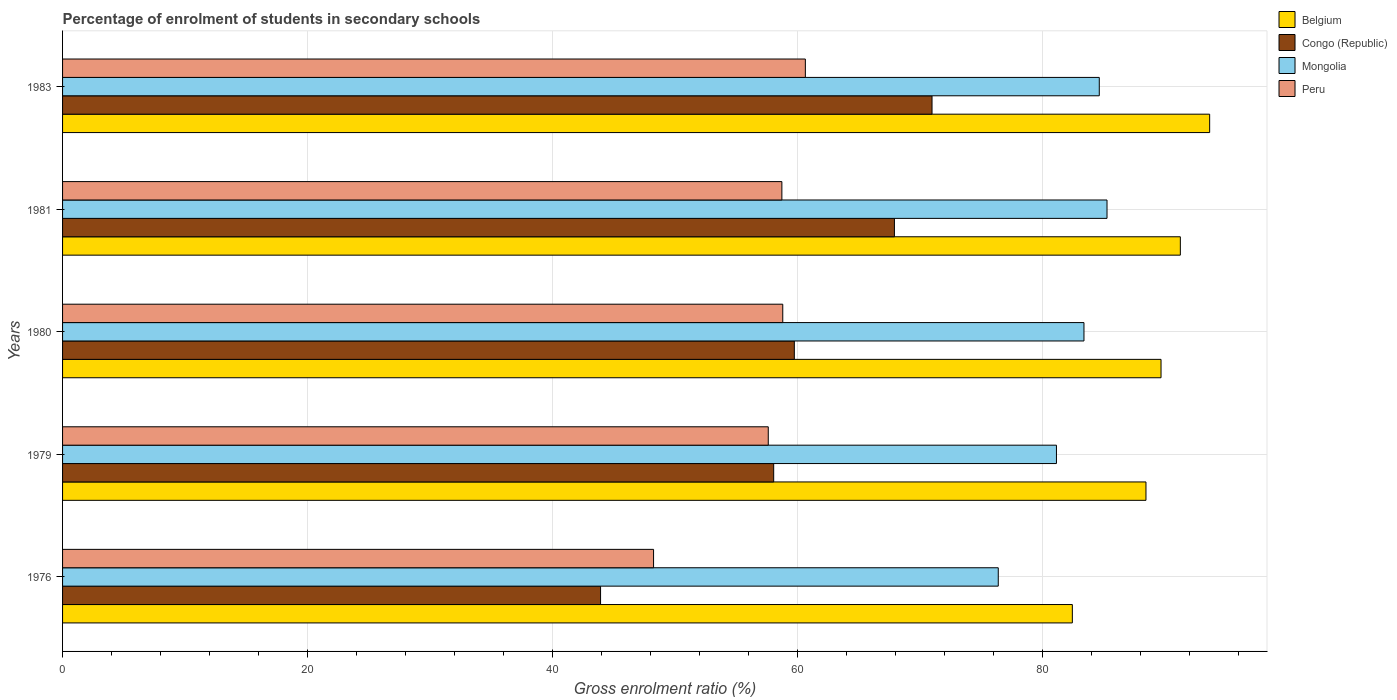How many different coloured bars are there?
Offer a very short reply. 4. How many groups of bars are there?
Provide a short and direct response. 5. Are the number of bars per tick equal to the number of legend labels?
Make the answer very short. Yes. What is the label of the 5th group of bars from the top?
Your answer should be compact. 1976. In how many cases, is the number of bars for a given year not equal to the number of legend labels?
Provide a short and direct response. 0. What is the percentage of students enrolled in secondary schools in Mongolia in 1980?
Your answer should be compact. 83.42. Across all years, what is the maximum percentage of students enrolled in secondary schools in Mongolia?
Offer a very short reply. 85.3. Across all years, what is the minimum percentage of students enrolled in secondary schools in Congo (Republic)?
Provide a succinct answer. 43.94. In which year was the percentage of students enrolled in secondary schools in Peru maximum?
Your answer should be compact. 1983. In which year was the percentage of students enrolled in secondary schools in Mongolia minimum?
Your answer should be very brief. 1976. What is the total percentage of students enrolled in secondary schools in Belgium in the graph?
Offer a very short reply. 445.63. What is the difference between the percentage of students enrolled in secondary schools in Congo (Republic) in 1980 and that in 1983?
Ensure brevity in your answer.  -11.25. What is the difference between the percentage of students enrolled in secondary schools in Belgium in 1979 and the percentage of students enrolled in secondary schools in Congo (Republic) in 1976?
Your answer should be very brief. 44.54. What is the average percentage of students enrolled in secondary schools in Congo (Republic) per year?
Your response must be concise. 60.14. In the year 1976, what is the difference between the percentage of students enrolled in secondary schools in Belgium and percentage of students enrolled in secondary schools in Congo (Republic)?
Make the answer very short. 38.53. In how many years, is the percentage of students enrolled in secondary schools in Peru greater than 92 %?
Your answer should be compact. 0. What is the ratio of the percentage of students enrolled in secondary schools in Peru in 1976 to that in 1979?
Provide a short and direct response. 0.84. Is the percentage of students enrolled in secondary schools in Belgium in 1980 less than that in 1983?
Offer a terse response. Yes. Is the difference between the percentage of students enrolled in secondary schools in Belgium in 1976 and 1983 greater than the difference between the percentage of students enrolled in secondary schools in Congo (Republic) in 1976 and 1983?
Make the answer very short. Yes. What is the difference between the highest and the second highest percentage of students enrolled in secondary schools in Peru?
Ensure brevity in your answer.  1.84. What is the difference between the highest and the lowest percentage of students enrolled in secondary schools in Peru?
Keep it short and to the point. 12.4. What does the 2nd bar from the top in 1983 represents?
Offer a very short reply. Mongolia. What does the 2nd bar from the bottom in 1983 represents?
Your answer should be very brief. Congo (Republic). Is it the case that in every year, the sum of the percentage of students enrolled in secondary schools in Congo (Republic) and percentage of students enrolled in secondary schools in Peru is greater than the percentage of students enrolled in secondary schools in Belgium?
Provide a short and direct response. Yes. How many bars are there?
Offer a terse response. 20. What is the difference between two consecutive major ticks on the X-axis?
Your answer should be compact. 20. Are the values on the major ticks of X-axis written in scientific E-notation?
Offer a very short reply. No. Does the graph contain any zero values?
Provide a succinct answer. No. How many legend labels are there?
Provide a succinct answer. 4. How are the legend labels stacked?
Your answer should be compact. Vertical. What is the title of the graph?
Offer a very short reply. Percentage of enrolment of students in secondary schools. Does "Cuba" appear as one of the legend labels in the graph?
Ensure brevity in your answer.  No. What is the label or title of the Y-axis?
Ensure brevity in your answer.  Years. What is the Gross enrolment ratio (%) in Belgium in 1976?
Offer a very short reply. 82.47. What is the Gross enrolment ratio (%) in Congo (Republic) in 1976?
Provide a short and direct response. 43.94. What is the Gross enrolment ratio (%) in Mongolia in 1976?
Provide a succinct answer. 76.42. What is the Gross enrolment ratio (%) in Peru in 1976?
Your answer should be compact. 48.27. What is the Gross enrolment ratio (%) of Belgium in 1979?
Make the answer very short. 88.48. What is the Gross enrolment ratio (%) of Congo (Republic) in 1979?
Provide a succinct answer. 58.08. What is the Gross enrolment ratio (%) in Mongolia in 1979?
Keep it short and to the point. 81.17. What is the Gross enrolment ratio (%) of Peru in 1979?
Your response must be concise. 57.63. What is the Gross enrolment ratio (%) in Belgium in 1980?
Make the answer very short. 89.71. What is the Gross enrolment ratio (%) in Congo (Republic) in 1980?
Make the answer very short. 59.76. What is the Gross enrolment ratio (%) in Mongolia in 1980?
Offer a very short reply. 83.42. What is the Gross enrolment ratio (%) in Peru in 1980?
Offer a very short reply. 58.82. What is the Gross enrolment ratio (%) of Belgium in 1981?
Make the answer very short. 91.29. What is the Gross enrolment ratio (%) in Congo (Republic) in 1981?
Provide a succinct answer. 67.94. What is the Gross enrolment ratio (%) in Mongolia in 1981?
Offer a very short reply. 85.3. What is the Gross enrolment ratio (%) of Peru in 1981?
Provide a succinct answer. 58.74. What is the Gross enrolment ratio (%) of Belgium in 1983?
Your answer should be compact. 93.68. What is the Gross enrolment ratio (%) of Congo (Republic) in 1983?
Provide a short and direct response. 71.01. What is the Gross enrolment ratio (%) in Mongolia in 1983?
Ensure brevity in your answer.  84.67. What is the Gross enrolment ratio (%) in Peru in 1983?
Your answer should be compact. 60.66. Across all years, what is the maximum Gross enrolment ratio (%) in Belgium?
Offer a very short reply. 93.68. Across all years, what is the maximum Gross enrolment ratio (%) in Congo (Republic)?
Give a very brief answer. 71.01. Across all years, what is the maximum Gross enrolment ratio (%) of Mongolia?
Your response must be concise. 85.3. Across all years, what is the maximum Gross enrolment ratio (%) of Peru?
Offer a terse response. 60.66. Across all years, what is the minimum Gross enrolment ratio (%) in Belgium?
Offer a terse response. 82.47. Across all years, what is the minimum Gross enrolment ratio (%) in Congo (Republic)?
Your answer should be very brief. 43.94. Across all years, what is the minimum Gross enrolment ratio (%) in Mongolia?
Provide a succinct answer. 76.42. Across all years, what is the minimum Gross enrolment ratio (%) of Peru?
Offer a terse response. 48.27. What is the total Gross enrolment ratio (%) in Belgium in the graph?
Your answer should be very brief. 445.63. What is the total Gross enrolment ratio (%) of Congo (Republic) in the graph?
Provide a short and direct response. 300.72. What is the total Gross enrolment ratio (%) of Mongolia in the graph?
Offer a very short reply. 410.97. What is the total Gross enrolment ratio (%) in Peru in the graph?
Ensure brevity in your answer.  284.12. What is the difference between the Gross enrolment ratio (%) in Belgium in 1976 and that in 1979?
Provide a short and direct response. -6.01. What is the difference between the Gross enrolment ratio (%) of Congo (Republic) in 1976 and that in 1979?
Ensure brevity in your answer.  -14.14. What is the difference between the Gross enrolment ratio (%) of Mongolia in 1976 and that in 1979?
Give a very brief answer. -4.75. What is the difference between the Gross enrolment ratio (%) in Peru in 1976 and that in 1979?
Your response must be concise. -9.37. What is the difference between the Gross enrolment ratio (%) of Belgium in 1976 and that in 1980?
Make the answer very short. -7.24. What is the difference between the Gross enrolment ratio (%) of Congo (Republic) in 1976 and that in 1980?
Your response must be concise. -15.82. What is the difference between the Gross enrolment ratio (%) of Mongolia in 1976 and that in 1980?
Give a very brief answer. -7. What is the difference between the Gross enrolment ratio (%) of Peru in 1976 and that in 1980?
Your response must be concise. -10.55. What is the difference between the Gross enrolment ratio (%) of Belgium in 1976 and that in 1981?
Ensure brevity in your answer.  -8.82. What is the difference between the Gross enrolment ratio (%) of Congo (Republic) in 1976 and that in 1981?
Keep it short and to the point. -24. What is the difference between the Gross enrolment ratio (%) of Mongolia in 1976 and that in 1981?
Keep it short and to the point. -8.88. What is the difference between the Gross enrolment ratio (%) in Peru in 1976 and that in 1981?
Your answer should be compact. -10.48. What is the difference between the Gross enrolment ratio (%) of Belgium in 1976 and that in 1983?
Keep it short and to the point. -11.21. What is the difference between the Gross enrolment ratio (%) in Congo (Republic) in 1976 and that in 1983?
Provide a succinct answer. -27.07. What is the difference between the Gross enrolment ratio (%) of Mongolia in 1976 and that in 1983?
Offer a very short reply. -8.25. What is the difference between the Gross enrolment ratio (%) in Peru in 1976 and that in 1983?
Offer a very short reply. -12.4. What is the difference between the Gross enrolment ratio (%) in Belgium in 1979 and that in 1980?
Keep it short and to the point. -1.23. What is the difference between the Gross enrolment ratio (%) of Congo (Republic) in 1979 and that in 1980?
Your answer should be compact. -1.69. What is the difference between the Gross enrolment ratio (%) of Mongolia in 1979 and that in 1980?
Make the answer very short. -2.25. What is the difference between the Gross enrolment ratio (%) of Peru in 1979 and that in 1980?
Make the answer very short. -1.18. What is the difference between the Gross enrolment ratio (%) in Belgium in 1979 and that in 1981?
Keep it short and to the point. -2.81. What is the difference between the Gross enrolment ratio (%) in Congo (Republic) in 1979 and that in 1981?
Ensure brevity in your answer.  -9.86. What is the difference between the Gross enrolment ratio (%) of Mongolia in 1979 and that in 1981?
Give a very brief answer. -4.13. What is the difference between the Gross enrolment ratio (%) in Peru in 1979 and that in 1981?
Ensure brevity in your answer.  -1.11. What is the difference between the Gross enrolment ratio (%) in Belgium in 1979 and that in 1983?
Keep it short and to the point. -5.2. What is the difference between the Gross enrolment ratio (%) of Congo (Republic) in 1979 and that in 1983?
Keep it short and to the point. -12.93. What is the difference between the Gross enrolment ratio (%) in Mongolia in 1979 and that in 1983?
Your answer should be compact. -3.5. What is the difference between the Gross enrolment ratio (%) in Peru in 1979 and that in 1983?
Your response must be concise. -3.03. What is the difference between the Gross enrolment ratio (%) in Belgium in 1980 and that in 1981?
Offer a very short reply. -1.58. What is the difference between the Gross enrolment ratio (%) in Congo (Republic) in 1980 and that in 1981?
Your response must be concise. -8.18. What is the difference between the Gross enrolment ratio (%) of Mongolia in 1980 and that in 1981?
Ensure brevity in your answer.  -1.88. What is the difference between the Gross enrolment ratio (%) in Peru in 1980 and that in 1981?
Offer a very short reply. 0.07. What is the difference between the Gross enrolment ratio (%) of Belgium in 1980 and that in 1983?
Your response must be concise. -3.97. What is the difference between the Gross enrolment ratio (%) of Congo (Republic) in 1980 and that in 1983?
Your answer should be very brief. -11.25. What is the difference between the Gross enrolment ratio (%) of Mongolia in 1980 and that in 1983?
Give a very brief answer. -1.25. What is the difference between the Gross enrolment ratio (%) of Peru in 1980 and that in 1983?
Offer a very short reply. -1.84. What is the difference between the Gross enrolment ratio (%) in Belgium in 1981 and that in 1983?
Keep it short and to the point. -2.39. What is the difference between the Gross enrolment ratio (%) in Congo (Republic) in 1981 and that in 1983?
Your answer should be compact. -3.07. What is the difference between the Gross enrolment ratio (%) of Mongolia in 1981 and that in 1983?
Offer a very short reply. 0.63. What is the difference between the Gross enrolment ratio (%) of Peru in 1981 and that in 1983?
Make the answer very short. -1.92. What is the difference between the Gross enrolment ratio (%) of Belgium in 1976 and the Gross enrolment ratio (%) of Congo (Republic) in 1979?
Make the answer very short. 24.39. What is the difference between the Gross enrolment ratio (%) in Belgium in 1976 and the Gross enrolment ratio (%) in Mongolia in 1979?
Your response must be concise. 1.3. What is the difference between the Gross enrolment ratio (%) in Belgium in 1976 and the Gross enrolment ratio (%) in Peru in 1979?
Your response must be concise. 24.83. What is the difference between the Gross enrolment ratio (%) of Congo (Republic) in 1976 and the Gross enrolment ratio (%) of Mongolia in 1979?
Your answer should be very brief. -37.23. What is the difference between the Gross enrolment ratio (%) in Congo (Republic) in 1976 and the Gross enrolment ratio (%) in Peru in 1979?
Offer a terse response. -13.7. What is the difference between the Gross enrolment ratio (%) in Mongolia in 1976 and the Gross enrolment ratio (%) in Peru in 1979?
Offer a terse response. 18.78. What is the difference between the Gross enrolment ratio (%) in Belgium in 1976 and the Gross enrolment ratio (%) in Congo (Republic) in 1980?
Give a very brief answer. 22.71. What is the difference between the Gross enrolment ratio (%) of Belgium in 1976 and the Gross enrolment ratio (%) of Mongolia in 1980?
Your response must be concise. -0.95. What is the difference between the Gross enrolment ratio (%) of Belgium in 1976 and the Gross enrolment ratio (%) of Peru in 1980?
Give a very brief answer. 23.65. What is the difference between the Gross enrolment ratio (%) in Congo (Republic) in 1976 and the Gross enrolment ratio (%) in Mongolia in 1980?
Your answer should be very brief. -39.48. What is the difference between the Gross enrolment ratio (%) in Congo (Republic) in 1976 and the Gross enrolment ratio (%) in Peru in 1980?
Provide a short and direct response. -14.88. What is the difference between the Gross enrolment ratio (%) in Mongolia in 1976 and the Gross enrolment ratio (%) in Peru in 1980?
Give a very brief answer. 17.6. What is the difference between the Gross enrolment ratio (%) in Belgium in 1976 and the Gross enrolment ratio (%) in Congo (Republic) in 1981?
Offer a very short reply. 14.53. What is the difference between the Gross enrolment ratio (%) of Belgium in 1976 and the Gross enrolment ratio (%) of Mongolia in 1981?
Your answer should be compact. -2.83. What is the difference between the Gross enrolment ratio (%) in Belgium in 1976 and the Gross enrolment ratio (%) in Peru in 1981?
Make the answer very short. 23.72. What is the difference between the Gross enrolment ratio (%) in Congo (Republic) in 1976 and the Gross enrolment ratio (%) in Mongolia in 1981?
Keep it short and to the point. -41.36. What is the difference between the Gross enrolment ratio (%) of Congo (Republic) in 1976 and the Gross enrolment ratio (%) of Peru in 1981?
Provide a succinct answer. -14.81. What is the difference between the Gross enrolment ratio (%) in Mongolia in 1976 and the Gross enrolment ratio (%) in Peru in 1981?
Give a very brief answer. 17.67. What is the difference between the Gross enrolment ratio (%) of Belgium in 1976 and the Gross enrolment ratio (%) of Congo (Republic) in 1983?
Your answer should be very brief. 11.46. What is the difference between the Gross enrolment ratio (%) in Belgium in 1976 and the Gross enrolment ratio (%) in Mongolia in 1983?
Keep it short and to the point. -2.2. What is the difference between the Gross enrolment ratio (%) in Belgium in 1976 and the Gross enrolment ratio (%) in Peru in 1983?
Offer a terse response. 21.81. What is the difference between the Gross enrolment ratio (%) in Congo (Republic) in 1976 and the Gross enrolment ratio (%) in Mongolia in 1983?
Your answer should be very brief. -40.73. What is the difference between the Gross enrolment ratio (%) in Congo (Republic) in 1976 and the Gross enrolment ratio (%) in Peru in 1983?
Keep it short and to the point. -16.73. What is the difference between the Gross enrolment ratio (%) in Mongolia in 1976 and the Gross enrolment ratio (%) in Peru in 1983?
Ensure brevity in your answer.  15.75. What is the difference between the Gross enrolment ratio (%) in Belgium in 1979 and the Gross enrolment ratio (%) in Congo (Republic) in 1980?
Make the answer very short. 28.72. What is the difference between the Gross enrolment ratio (%) in Belgium in 1979 and the Gross enrolment ratio (%) in Mongolia in 1980?
Keep it short and to the point. 5.06. What is the difference between the Gross enrolment ratio (%) in Belgium in 1979 and the Gross enrolment ratio (%) in Peru in 1980?
Ensure brevity in your answer.  29.66. What is the difference between the Gross enrolment ratio (%) in Congo (Republic) in 1979 and the Gross enrolment ratio (%) in Mongolia in 1980?
Keep it short and to the point. -25.34. What is the difference between the Gross enrolment ratio (%) of Congo (Republic) in 1979 and the Gross enrolment ratio (%) of Peru in 1980?
Make the answer very short. -0.74. What is the difference between the Gross enrolment ratio (%) in Mongolia in 1979 and the Gross enrolment ratio (%) in Peru in 1980?
Keep it short and to the point. 22.35. What is the difference between the Gross enrolment ratio (%) in Belgium in 1979 and the Gross enrolment ratio (%) in Congo (Republic) in 1981?
Offer a very short reply. 20.54. What is the difference between the Gross enrolment ratio (%) in Belgium in 1979 and the Gross enrolment ratio (%) in Mongolia in 1981?
Make the answer very short. 3.18. What is the difference between the Gross enrolment ratio (%) in Belgium in 1979 and the Gross enrolment ratio (%) in Peru in 1981?
Give a very brief answer. 29.73. What is the difference between the Gross enrolment ratio (%) of Congo (Republic) in 1979 and the Gross enrolment ratio (%) of Mongolia in 1981?
Provide a succinct answer. -27.22. What is the difference between the Gross enrolment ratio (%) in Congo (Republic) in 1979 and the Gross enrolment ratio (%) in Peru in 1981?
Your response must be concise. -0.67. What is the difference between the Gross enrolment ratio (%) in Mongolia in 1979 and the Gross enrolment ratio (%) in Peru in 1981?
Offer a very short reply. 22.42. What is the difference between the Gross enrolment ratio (%) of Belgium in 1979 and the Gross enrolment ratio (%) of Congo (Republic) in 1983?
Make the answer very short. 17.47. What is the difference between the Gross enrolment ratio (%) of Belgium in 1979 and the Gross enrolment ratio (%) of Mongolia in 1983?
Your response must be concise. 3.81. What is the difference between the Gross enrolment ratio (%) in Belgium in 1979 and the Gross enrolment ratio (%) in Peru in 1983?
Your answer should be very brief. 27.82. What is the difference between the Gross enrolment ratio (%) in Congo (Republic) in 1979 and the Gross enrolment ratio (%) in Mongolia in 1983?
Your answer should be compact. -26.59. What is the difference between the Gross enrolment ratio (%) of Congo (Republic) in 1979 and the Gross enrolment ratio (%) of Peru in 1983?
Offer a very short reply. -2.59. What is the difference between the Gross enrolment ratio (%) of Mongolia in 1979 and the Gross enrolment ratio (%) of Peru in 1983?
Give a very brief answer. 20.51. What is the difference between the Gross enrolment ratio (%) of Belgium in 1980 and the Gross enrolment ratio (%) of Congo (Republic) in 1981?
Keep it short and to the point. 21.77. What is the difference between the Gross enrolment ratio (%) in Belgium in 1980 and the Gross enrolment ratio (%) in Mongolia in 1981?
Offer a very short reply. 4.41. What is the difference between the Gross enrolment ratio (%) of Belgium in 1980 and the Gross enrolment ratio (%) of Peru in 1981?
Give a very brief answer. 30.97. What is the difference between the Gross enrolment ratio (%) in Congo (Republic) in 1980 and the Gross enrolment ratio (%) in Mongolia in 1981?
Ensure brevity in your answer.  -25.54. What is the difference between the Gross enrolment ratio (%) of Mongolia in 1980 and the Gross enrolment ratio (%) of Peru in 1981?
Give a very brief answer. 24.67. What is the difference between the Gross enrolment ratio (%) of Belgium in 1980 and the Gross enrolment ratio (%) of Congo (Republic) in 1983?
Offer a terse response. 18.7. What is the difference between the Gross enrolment ratio (%) in Belgium in 1980 and the Gross enrolment ratio (%) in Mongolia in 1983?
Make the answer very short. 5.04. What is the difference between the Gross enrolment ratio (%) in Belgium in 1980 and the Gross enrolment ratio (%) in Peru in 1983?
Give a very brief answer. 29.05. What is the difference between the Gross enrolment ratio (%) of Congo (Republic) in 1980 and the Gross enrolment ratio (%) of Mongolia in 1983?
Offer a terse response. -24.91. What is the difference between the Gross enrolment ratio (%) in Congo (Republic) in 1980 and the Gross enrolment ratio (%) in Peru in 1983?
Your response must be concise. -0.9. What is the difference between the Gross enrolment ratio (%) in Mongolia in 1980 and the Gross enrolment ratio (%) in Peru in 1983?
Your response must be concise. 22.75. What is the difference between the Gross enrolment ratio (%) in Belgium in 1981 and the Gross enrolment ratio (%) in Congo (Republic) in 1983?
Provide a short and direct response. 20.28. What is the difference between the Gross enrolment ratio (%) in Belgium in 1981 and the Gross enrolment ratio (%) in Mongolia in 1983?
Your response must be concise. 6.62. What is the difference between the Gross enrolment ratio (%) of Belgium in 1981 and the Gross enrolment ratio (%) of Peru in 1983?
Make the answer very short. 30.63. What is the difference between the Gross enrolment ratio (%) in Congo (Republic) in 1981 and the Gross enrolment ratio (%) in Mongolia in 1983?
Make the answer very short. -16.73. What is the difference between the Gross enrolment ratio (%) of Congo (Republic) in 1981 and the Gross enrolment ratio (%) of Peru in 1983?
Your response must be concise. 7.27. What is the difference between the Gross enrolment ratio (%) in Mongolia in 1981 and the Gross enrolment ratio (%) in Peru in 1983?
Give a very brief answer. 24.64. What is the average Gross enrolment ratio (%) of Belgium per year?
Your answer should be compact. 89.13. What is the average Gross enrolment ratio (%) of Congo (Republic) per year?
Offer a very short reply. 60.14. What is the average Gross enrolment ratio (%) of Mongolia per year?
Ensure brevity in your answer.  82.19. What is the average Gross enrolment ratio (%) in Peru per year?
Keep it short and to the point. 56.83. In the year 1976, what is the difference between the Gross enrolment ratio (%) in Belgium and Gross enrolment ratio (%) in Congo (Republic)?
Your answer should be compact. 38.53. In the year 1976, what is the difference between the Gross enrolment ratio (%) in Belgium and Gross enrolment ratio (%) in Mongolia?
Provide a succinct answer. 6.05. In the year 1976, what is the difference between the Gross enrolment ratio (%) of Belgium and Gross enrolment ratio (%) of Peru?
Give a very brief answer. 34.2. In the year 1976, what is the difference between the Gross enrolment ratio (%) in Congo (Republic) and Gross enrolment ratio (%) in Mongolia?
Give a very brief answer. -32.48. In the year 1976, what is the difference between the Gross enrolment ratio (%) in Congo (Republic) and Gross enrolment ratio (%) in Peru?
Make the answer very short. -4.33. In the year 1976, what is the difference between the Gross enrolment ratio (%) in Mongolia and Gross enrolment ratio (%) in Peru?
Provide a short and direct response. 28.15. In the year 1979, what is the difference between the Gross enrolment ratio (%) of Belgium and Gross enrolment ratio (%) of Congo (Republic)?
Provide a short and direct response. 30.4. In the year 1979, what is the difference between the Gross enrolment ratio (%) in Belgium and Gross enrolment ratio (%) in Mongolia?
Your answer should be very brief. 7.31. In the year 1979, what is the difference between the Gross enrolment ratio (%) in Belgium and Gross enrolment ratio (%) in Peru?
Your answer should be very brief. 30.85. In the year 1979, what is the difference between the Gross enrolment ratio (%) of Congo (Republic) and Gross enrolment ratio (%) of Mongolia?
Your response must be concise. -23.09. In the year 1979, what is the difference between the Gross enrolment ratio (%) of Congo (Republic) and Gross enrolment ratio (%) of Peru?
Your answer should be very brief. 0.44. In the year 1979, what is the difference between the Gross enrolment ratio (%) in Mongolia and Gross enrolment ratio (%) in Peru?
Offer a very short reply. 23.54. In the year 1980, what is the difference between the Gross enrolment ratio (%) in Belgium and Gross enrolment ratio (%) in Congo (Republic)?
Your answer should be very brief. 29.95. In the year 1980, what is the difference between the Gross enrolment ratio (%) of Belgium and Gross enrolment ratio (%) of Mongolia?
Keep it short and to the point. 6.29. In the year 1980, what is the difference between the Gross enrolment ratio (%) of Belgium and Gross enrolment ratio (%) of Peru?
Make the answer very short. 30.89. In the year 1980, what is the difference between the Gross enrolment ratio (%) of Congo (Republic) and Gross enrolment ratio (%) of Mongolia?
Your answer should be very brief. -23.66. In the year 1980, what is the difference between the Gross enrolment ratio (%) in Congo (Republic) and Gross enrolment ratio (%) in Peru?
Make the answer very short. 0.94. In the year 1980, what is the difference between the Gross enrolment ratio (%) of Mongolia and Gross enrolment ratio (%) of Peru?
Provide a short and direct response. 24.6. In the year 1981, what is the difference between the Gross enrolment ratio (%) in Belgium and Gross enrolment ratio (%) in Congo (Republic)?
Ensure brevity in your answer.  23.35. In the year 1981, what is the difference between the Gross enrolment ratio (%) of Belgium and Gross enrolment ratio (%) of Mongolia?
Make the answer very short. 5.99. In the year 1981, what is the difference between the Gross enrolment ratio (%) of Belgium and Gross enrolment ratio (%) of Peru?
Ensure brevity in your answer.  32.54. In the year 1981, what is the difference between the Gross enrolment ratio (%) of Congo (Republic) and Gross enrolment ratio (%) of Mongolia?
Your answer should be compact. -17.36. In the year 1981, what is the difference between the Gross enrolment ratio (%) of Congo (Republic) and Gross enrolment ratio (%) of Peru?
Give a very brief answer. 9.19. In the year 1981, what is the difference between the Gross enrolment ratio (%) of Mongolia and Gross enrolment ratio (%) of Peru?
Offer a terse response. 26.55. In the year 1983, what is the difference between the Gross enrolment ratio (%) in Belgium and Gross enrolment ratio (%) in Congo (Republic)?
Offer a very short reply. 22.67. In the year 1983, what is the difference between the Gross enrolment ratio (%) of Belgium and Gross enrolment ratio (%) of Mongolia?
Provide a short and direct response. 9.01. In the year 1983, what is the difference between the Gross enrolment ratio (%) in Belgium and Gross enrolment ratio (%) in Peru?
Offer a terse response. 33.02. In the year 1983, what is the difference between the Gross enrolment ratio (%) of Congo (Republic) and Gross enrolment ratio (%) of Mongolia?
Offer a terse response. -13.66. In the year 1983, what is the difference between the Gross enrolment ratio (%) of Congo (Republic) and Gross enrolment ratio (%) of Peru?
Offer a terse response. 10.35. In the year 1983, what is the difference between the Gross enrolment ratio (%) of Mongolia and Gross enrolment ratio (%) of Peru?
Your response must be concise. 24.01. What is the ratio of the Gross enrolment ratio (%) in Belgium in 1976 to that in 1979?
Ensure brevity in your answer.  0.93. What is the ratio of the Gross enrolment ratio (%) in Congo (Republic) in 1976 to that in 1979?
Ensure brevity in your answer.  0.76. What is the ratio of the Gross enrolment ratio (%) of Mongolia in 1976 to that in 1979?
Ensure brevity in your answer.  0.94. What is the ratio of the Gross enrolment ratio (%) in Peru in 1976 to that in 1979?
Make the answer very short. 0.84. What is the ratio of the Gross enrolment ratio (%) in Belgium in 1976 to that in 1980?
Keep it short and to the point. 0.92. What is the ratio of the Gross enrolment ratio (%) in Congo (Republic) in 1976 to that in 1980?
Keep it short and to the point. 0.74. What is the ratio of the Gross enrolment ratio (%) in Mongolia in 1976 to that in 1980?
Your answer should be compact. 0.92. What is the ratio of the Gross enrolment ratio (%) of Peru in 1976 to that in 1980?
Make the answer very short. 0.82. What is the ratio of the Gross enrolment ratio (%) of Belgium in 1976 to that in 1981?
Ensure brevity in your answer.  0.9. What is the ratio of the Gross enrolment ratio (%) of Congo (Republic) in 1976 to that in 1981?
Your answer should be very brief. 0.65. What is the ratio of the Gross enrolment ratio (%) in Mongolia in 1976 to that in 1981?
Offer a very short reply. 0.9. What is the ratio of the Gross enrolment ratio (%) of Peru in 1976 to that in 1981?
Your answer should be very brief. 0.82. What is the ratio of the Gross enrolment ratio (%) of Belgium in 1976 to that in 1983?
Your response must be concise. 0.88. What is the ratio of the Gross enrolment ratio (%) of Congo (Republic) in 1976 to that in 1983?
Offer a very short reply. 0.62. What is the ratio of the Gross enrolment ratio (%) of Mongolia in 1976 to that in 1983?
Your answer should be compact. 0.9. What is the ratio of the Gross enrolment ratio (%) in Peru in 1976 to that in 1983?
Your answer should be compact. 0.8. What is the ratio of the Gross enrolment ratio (%) in Belgium in 1979 to that in 1980?
Ensure brevity in your answer.  0.99. What is the ratio of the Gross enrolment ratio (%) of Congo (Republic) in 1979 to that in 1980?
Your response must be concise. 0.97. What is the ratio of the Gross enrolment ratio (%) of Mongolia in 1979 to that in 1980?
Provide a short and direct response. 0.97. What is the ratio of the Gross enrolment ratio (%) of Peru in 1979 to that in 1980?
Provide a succinct answer. 0.98. What is the ratio of the Gross enrolment ratio (%) in Belgium in 1979 to that in 1981?
Provide a short and direct response. 0.97. What is the ratio of the Gross enrolment ratio (%) of Congo (Republic) in 1979 to that in 1981?
Keep it short and to the point. 0.85. What is the ratio of the Gross enrolment ratio (%) in Mongolia in 1979 to that in 1981?
Your answer should be compact. 0.95. What is the ratio of the Gross enrolment ratio (%) of Peru in 1979 to that in 1981?
Make the answer very short. 0.98. What is the ratio of the Gross enrolment ratio (%) of Belgium in 1979 to that in 1983?
Offer a terse response. 0.94. What is the ratio of the Gross enrolment ratio (%) in Congo (Republic) in 1979 to that in 1983?
Your response must be concise. 0.82. What is the ratio of the Gross enrolment ratio (%) in Mongolia in 1979 to that in 1983?
Your answer should be very brief. 0.96. What is the ratio of the Gross enrolment ratio (%) in Peru in 1979 to that in 1983?
Your answer should be very brief. 0.95. What is the ratio of the Gross enrolment ratio (%) in Belgium in 1980 to that in 1981?
Ensure brevity in your answer.  0.98. What is the ratio of the Gross enrolment ratio (%) in Congo (Republic) in 1980 to that in 1981?
Provide a succinct answer. 0.88. What is the ratio of the Gross enrolment ratio (%) in Mongolia in 1980 to that in 1981?
Make the answer very short. 0.98. What is the ratio of the Gross enrolment ratio (%) in Peru in 1980 to that in 1981?
Ensure brevity in your answer.  1. What is the ratio of the Gross enrolment ratio (%) of Belgium in 1980 to that in 1983?
Provide a short and direct response. 0.96. What is the ratio of the Gross enrolment ratio (%) of Congo (Republic) in 1980 to that in 1983?
Ensure brevity in your answer.  0.84. What is the ratio of the Gross enrolment ratio (%) in Mongolia in 1980 to that in 1983?
Your answer should be very brief. 0.99. What is the ratio of the Gross enrolment ratio (%) of Peru in 1980 to that in 1983?
Make the answer very short. 0.97. What is the ratio of the Gross enrolment ratio (%) of Belgium in 1981 to that in 1983?
Offer a terse response. 0.97. What is the ratio of the Gross enrolment ratio (%) in Congo (Republic) in 1981 to that in 1983?
Ensure brevity in your answer.  0.96. What is the ratio of the Gross enrolment ratio (%) of Mongolia in 1981 to that in 1983?
Give a very brief answer. 1.01. What is the ratio of the Gross enrolment ratio (%) in Peru in 1981 to that in 1983?
Your response must be concise. 0.97. What is the difference between the highest and the second highest Gross enrolment ratio (%) in Belgium?
Provide a short and direct response. 2.39. What is the difference between the highest and the second highest Gross enrolment ratio (%) of Congo (Republic)?
Your response must be concise. 3.07. What is the difference between the highest and the second highest Gross enrolment ratio (%) of Mongolia?
Your response must be concise. 0.63. What is the difference between the highest and the second highest Gross enrolment ratio (%) of Peru?
Keep it short and to the point. 1.84. What is the difference between the highest and the lowest Gross enrolment ratio (%) of Belgium?
Keep it short and to the point. 11.21. What is the difference between the highest and the lowest Gross enrolment ratio (%) of Congo (Republic)?
Your answer should be very brief. 27.07. What is the difference between the highest and the lowest Gross enrolment ratio (%) in Mongolia?
Provide a succinct answer. 8.88. What is the difference between the highest and the lowest Gross enrolment ratio (%) of Peru?
Provide a succinct answer. 12.4. 